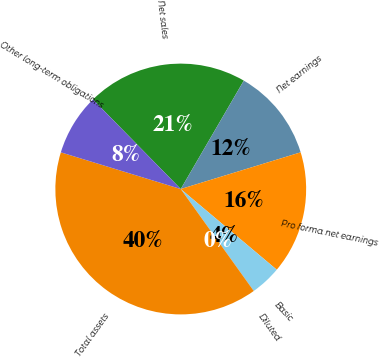Convert chart. <chart><loc_0><loc_0><loc_500><loc_500><pie_chart><fcel>Net sales<fcel>Net earnings<fcel>Pro forma net earnings<fcel>Basic<fcel>Diluted<fcel>Total assets<fcel>Other long-term obligations<nl><fcel>20.73%<fcel>11.89%<fcel>15.85%<fcel>3.97%<fcel>0.02%<fcel>39.61%<fcel>7.93%<nl></chart> 